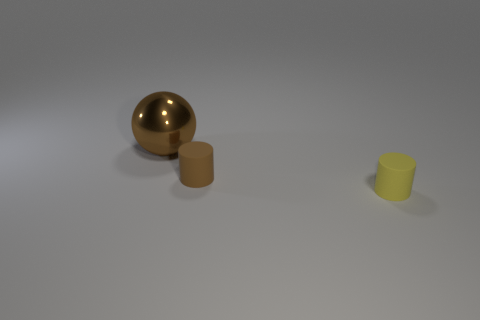There is a sphere; does it have the same color as the rubber cylinder to the left of the small yellow matte object?
Ensure brevity in your answer.  Yes. The small matte thing that is on the right side of the cylinder behind the tiny yellow cylinder is what color?
Offer a very short reply. Yellow. There is a tiny object on the left side of the tiny matte thing that is to the right of the small brown rubber thing; is there a big ball that is behind it?
Make the answer very short. Yes. The other small thing that is the same material as the yellow thing is what color?
Provide a short and direct response. Brown. What number of yellow cylinders are the same material as the brown cylinder?
Your answer should be compact. 1. Is the material of the yellow object the same as the brown object that is right of the big ball?
Give a very brief answer. Yes. How many objects are either matte cylinders that are behind the yellow rubber thing or big brown shiny blocks?
Your answer should be very brief. 1. What size is the brown thing that is on the right side of the object that is behind the brown object that is to the right of the big brown metal object?
Provide a succinct answer. Small. What is the material of the other thing that is the same color as the big metal thing?
Offer a terse response. Rubber. Is there anything else that is the same shape as the large brown metal thing?
Give a very brief answer. No. 